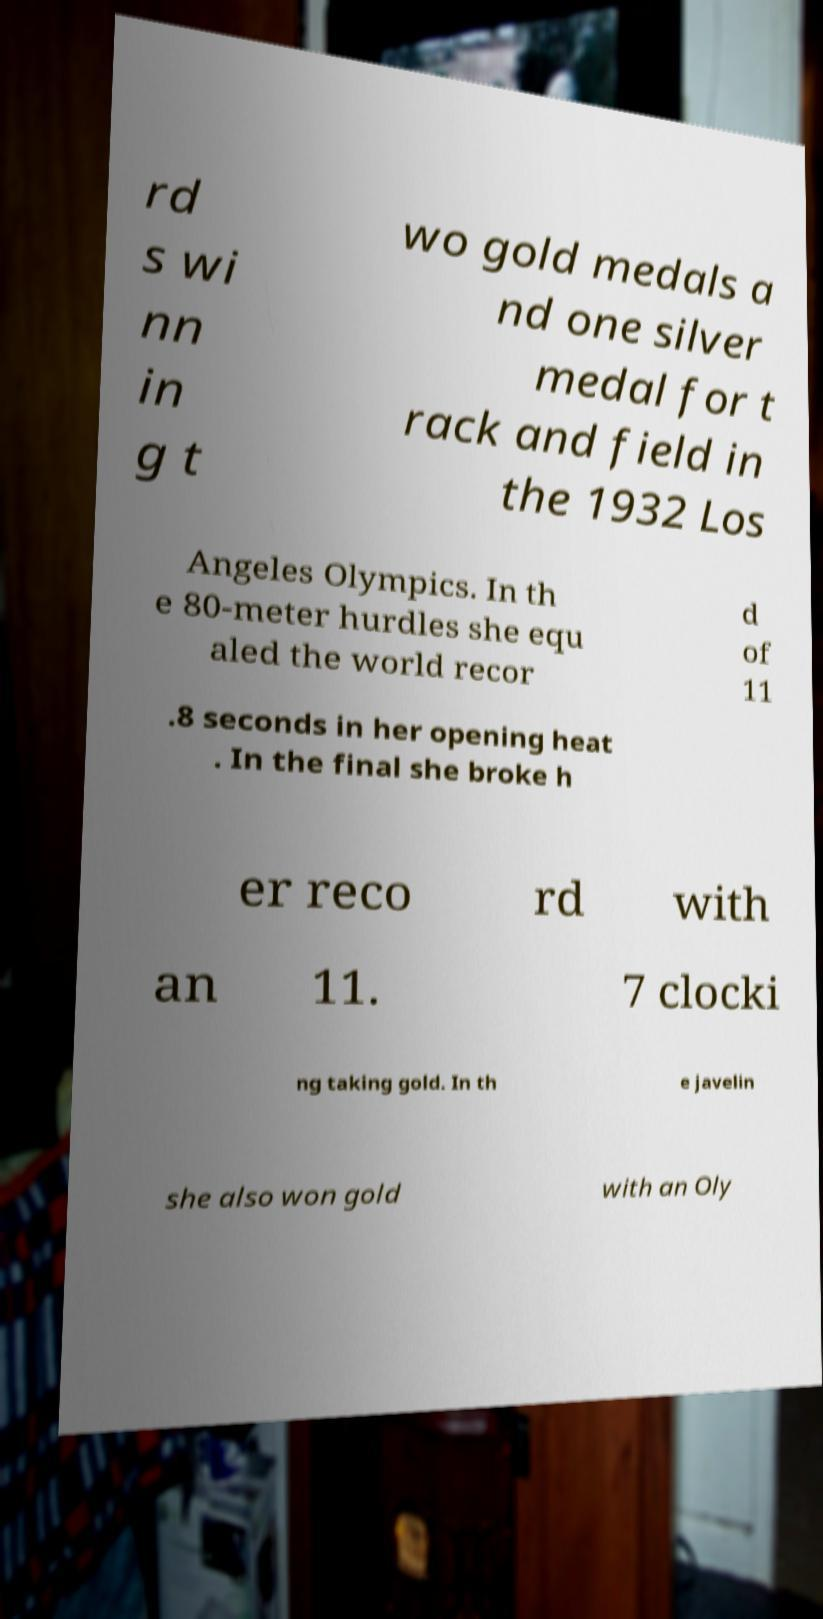I need the written content from this picture converted into text. Can you do that? rd s wi nn in g t wo gold medals a nd one silver medal for t rack and field in the 1932 Los Angeles Olympics. In th e 80-meter hurdles she equ aled the world recor d of 11 .8 seconds in her opening heat . In the final she broke h er reco rd with an 11. 7 clocki ng taking gold. In th e javelin she also won gold with an Oly 